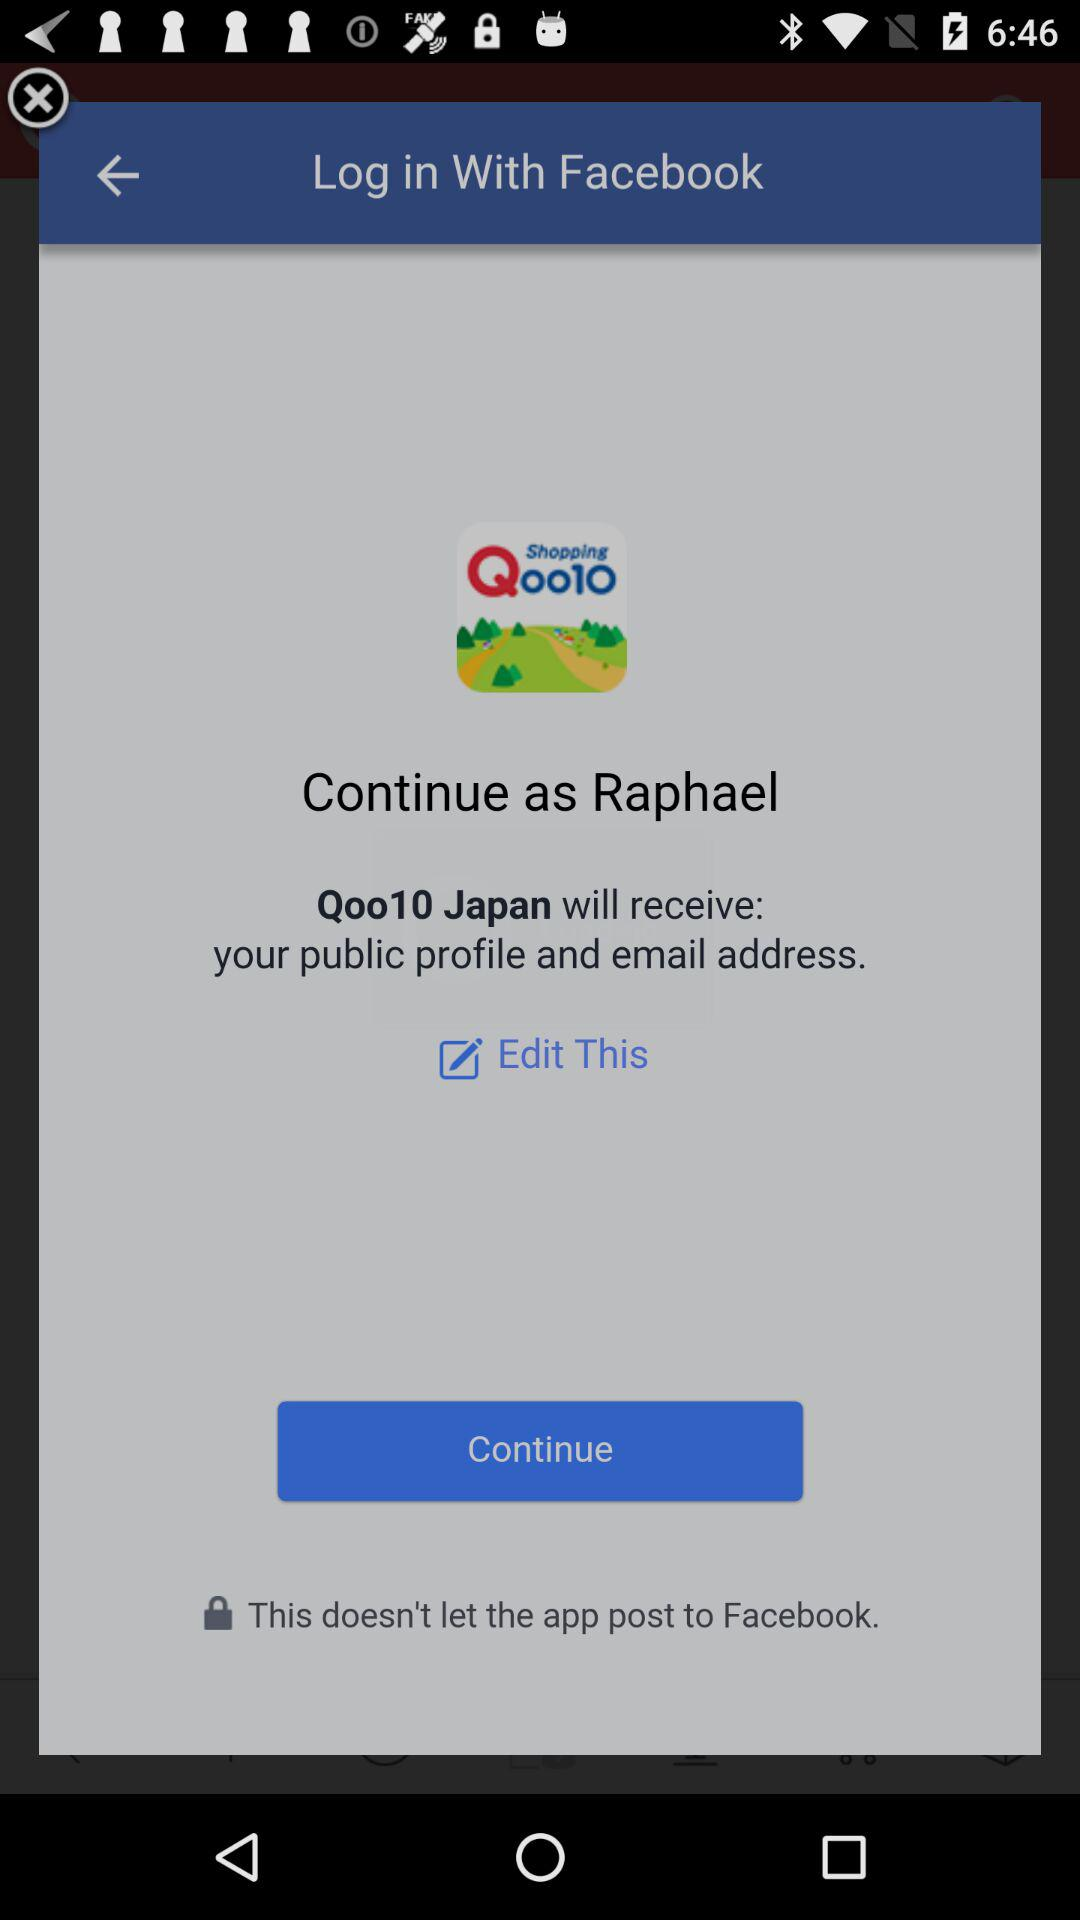What is the name of the user? The name of the user is Raphael. 